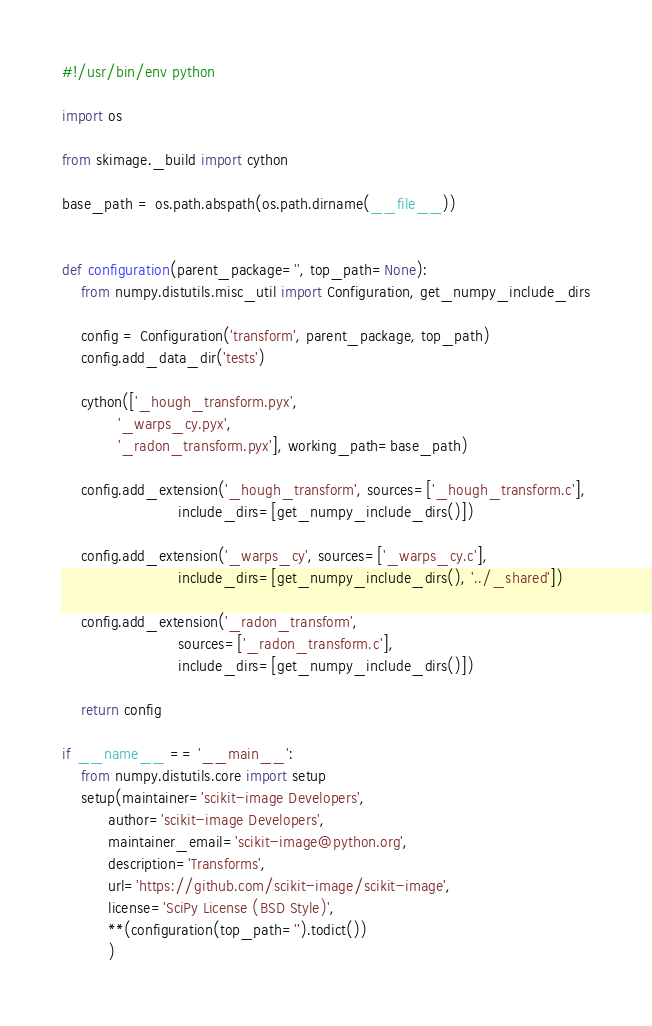Convert code to text. <code><loc_0><loc_0><loc_500><loc_500><_Python_>#!/usr/bin/env python

import os

from skimage._build import cython

base_path = os.path.abspath(os.path.dirname(__file__))


def configuration(parent_package='', top_path=None):
    from numpy.distutils.misc_util import Configuration, get_numpy_include_dirs

    config = Configuration('transform', parent_package, top_path)
    config.add_data_dir('tests')

    cython(['_hough_transform.pyx',
            '_warps_cy.pyx',
            '_radon_transform.pyx'], working_path=base_path)

    config.add_extension('_hough_transform', sources=['_hough_transform.c'],
                         include_dirs=[get_numpy_include_dirs()])

    config.add_extension('_warps_cy', sources=['_warps_cy.c'],
                         include_dirs=[get_numpy_include_dirs(), '../_shared'])

    config.add_extension('_radon_transform',
                         sources=['_radon_transform.c'],
                         include_dirs=[get_numpy_include_dirs()])

    return config

if __name__ == '__main__':
    from numpy.distutils.core import setup
    setup(maintainer='scikit-image Developers',
          author='scikit-image Developers',
          maintainer_email='scikit-image@python.org',
          description='Transforms',
          url='https://github.com/scikit-image/scikit-image',
          license='SciPy License (BSD Style)',
          **(configuration(top_path='').todict())
          )
</code> 